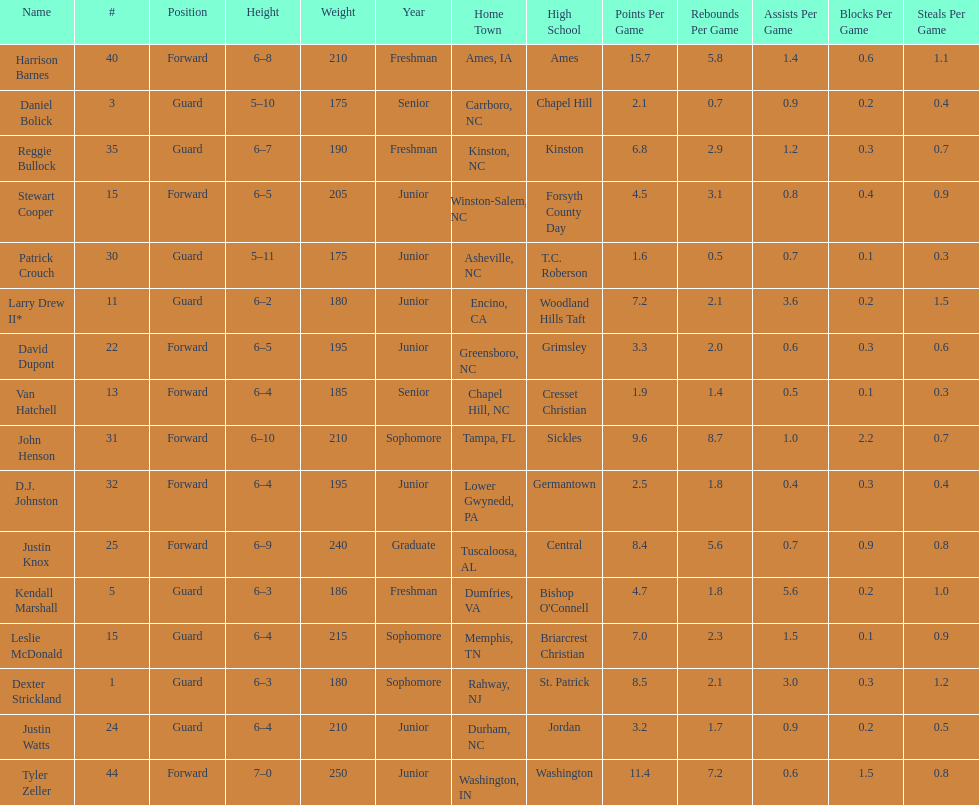How many players play a position other than guard? 8. Can you parse all the data within this table? {'header': ['Name', '#', 'Position', 'Height', 'Weight', 'Year', 'Home Town', 'High School', 'Points Per Game', 'Rebounds Per Game', 'Assists Per Game', 'Blocks Per Game', 'Steals Per Game'], 'rows': [['Harrison Barnes', '40', 'Forward', '6–8', '210', 'Freshman', 'Ames, IA', 'Ames', '15.7', '5.8', '1.4', '0.6', '1.1'], ['Daniel Bolick', '3', 'Guard', '5–10', '175', 'Senior', 'Carrboro, NC', 'Chapel Hill', '2.1', '0.7', '0.9', '0.2', '0.4'], ['Reggie Bullock', '35', 'Guard', '6–7', '190', 'Freshman', 'Kinston, NC', 'Kinston', '6.8', '2.9', '1.2', '0.3', '0.7'], ['Stewart Cooper', '15', 'Forward', '6–5', '205', 'Junior', 'Winston-Salem, NC', 'Forsyth County Day', '4.5', '3.1', '0.8', '0.4', '0.9'], ['Patrick Crouch', '30', 'Guard', '5–11', '175', 'Junior', 'Asheville, NC', 'T.C. Roberson', '1.6', '0.5', '0.7', '0.1', '0.3'], ['Larry Drew II*', '11', 'Guard', '6–2', '180', 'Junior', 'Encino, CA', 'Woodland Hills Taft', '7.2', '2.1', '3.6', '0.2', '1.5'], ['David Dupont', '22', 'Forward', '6–5', '195', 'Junior', 'Greensboro, NC', 'Grimsley', '3.3', '2.0', '0.6', '0.3', '0.6'], ['Van Hatchell', '13', 'Forward', '6–4', '185', 'Senior', 'Chapel Hill, NC', 'Cresset Christian', '1.9', '1.4', '0.5', '0.1', '0.3'], ['John Henson', '31', 'Forward', '6–10', '210', 'Sophomore', 'Tampa, FL', 'Sickles', '9.6', '8.7', '1.0', '2.2', '0.7'], ['D.J. Johnston', '32', 'Forward', '6–4', '195', 'Junior', 'Lower Gwynedd, PA', 'Germantown', '2.5', '1.8', '0.4', '0.3', '0.4'], ['Justin Knox', '25', 'Forward', '6–9', '240', 'Graduate', 'Tuscaloosa, AL', 'Central', '8.4', '5.6', '0.7', '0.9', '0.8'], ['Kendall Marshall', '5', 'Guard', '6–3', '186', 'Freshman', 'Dumfries, VA', "Bishop O'Connell", '4.7', '1.8', '5.6', '0.2', '1.0'], ['Leslie McDonald', '15', 'Guard', '6–4', '215', 'Sophomore', 'Memphis, TN', 'Briarcrest Christian', '7.0', '2.3', '1.5', '0.1', '0.9'], ['Dexter Strickland', '1', 'Guard', '6–3', '180', 'Sophomore', 'Rahway, NJ', 'St. Patrick', '8.5', '2.1', '3.0', '0.3', '1.2'], ['Justin Watts', '24', 'Guard', '6–4', '210', 'Junior', 'Durham, NC', 'Jordan', '3.2', '1.7', '0.9', '0.2', '0.5'], ['Tyler Zeller', '44', 'Forward', '7–0', '250', 'Junior', 'Washington, IN', 'Washington', '11.4', '7.2', '0.6', '1.5', '0.8']]} 